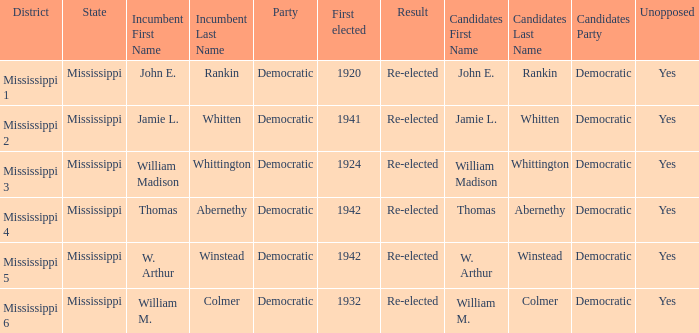What is the result for w. arthur winstead? Re-elected. 